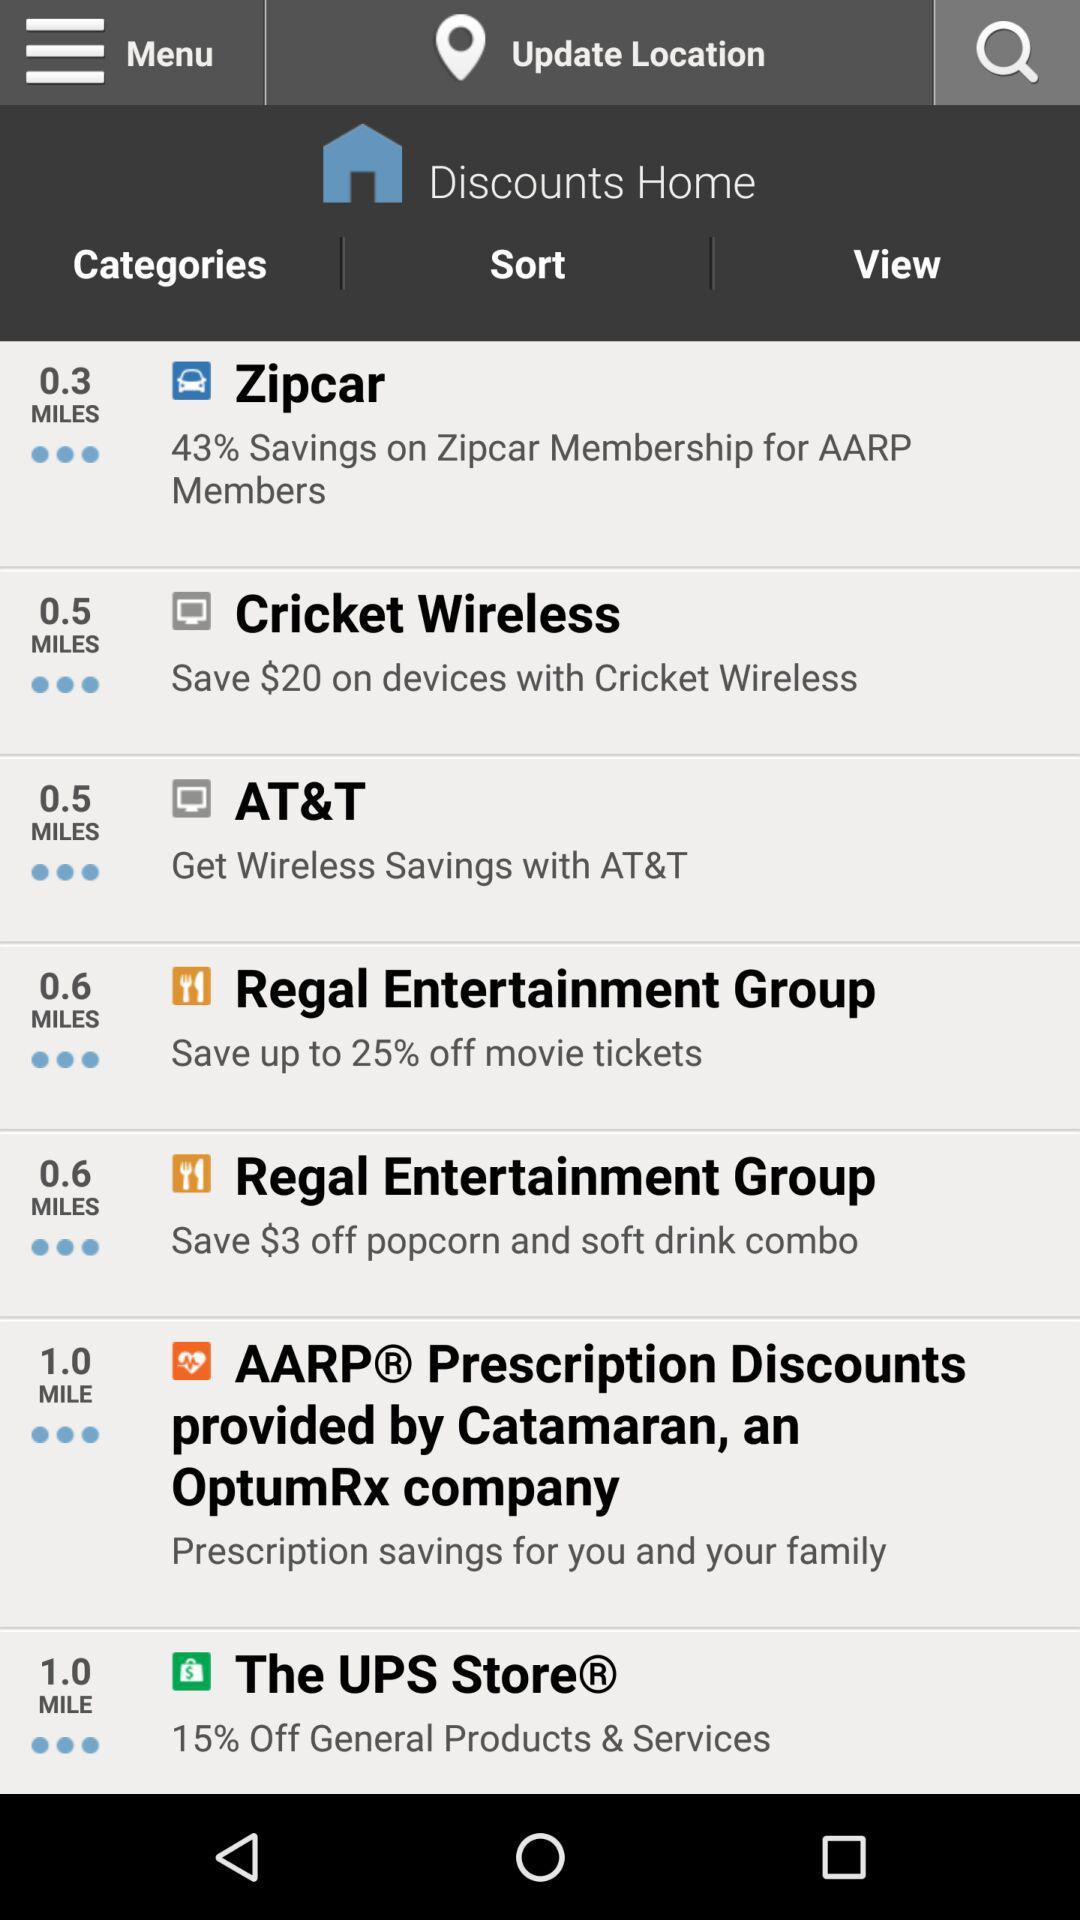How many dollars could be saved on a popcorn and soft drink combo at "Regal Entertainment Group"? The amount that could be saved on a popcorn and soft drink combo at "Regal Entertainment Group" is $3. 